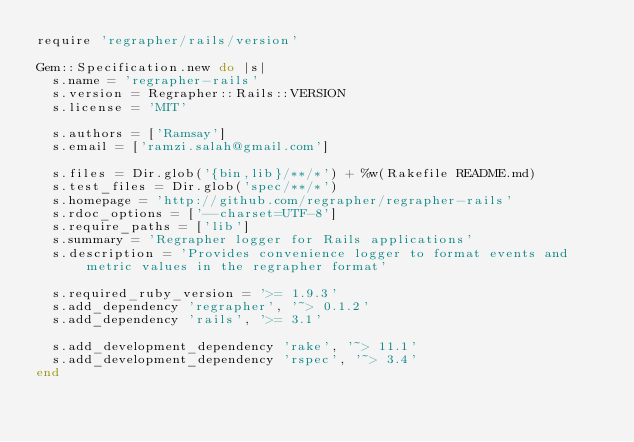<code> <loc_0><loc_0><loc_500><loc_500><_Ruby_>require 'regrapher/rails/version'

Gem::Specification.new do |s|
  s.name = 'regrapher-rails'
  s.version = Regrapher::Rails::VERSION
  s.license = 'MIT'

  s.authors = ['Ramsay']
  s.email = ['ramzi.salah@gmail.com']

  s.files = Dir.glob('{bin,lib}/**/*') + %w(Rakefile README.md)
  s.test_files = Dir.glob('spec/**/*')
  s.homepage = 'http://github.com/regrapher/regrapher-rails'
  s.rdoc_options = ['--charset=UTF-8']
  s.require_paths = ['lib']
  s.summary = 'Regrapher logger for Rails applications'
  s.description = 'Provides convenience logger to format events and metric values in the regrapher format'

  s.required_ruby_version = '>= 1.9.3'
  s.add_dependency 'regrapher', '~> 0.1.2'
  s.add_dependency 'rails', '>= 3.1'

  s.add_development_dependency 'rake', '~> 11.1'
  s.add_development_dependency 'rspec', '~> 3.4'
end
</code> 